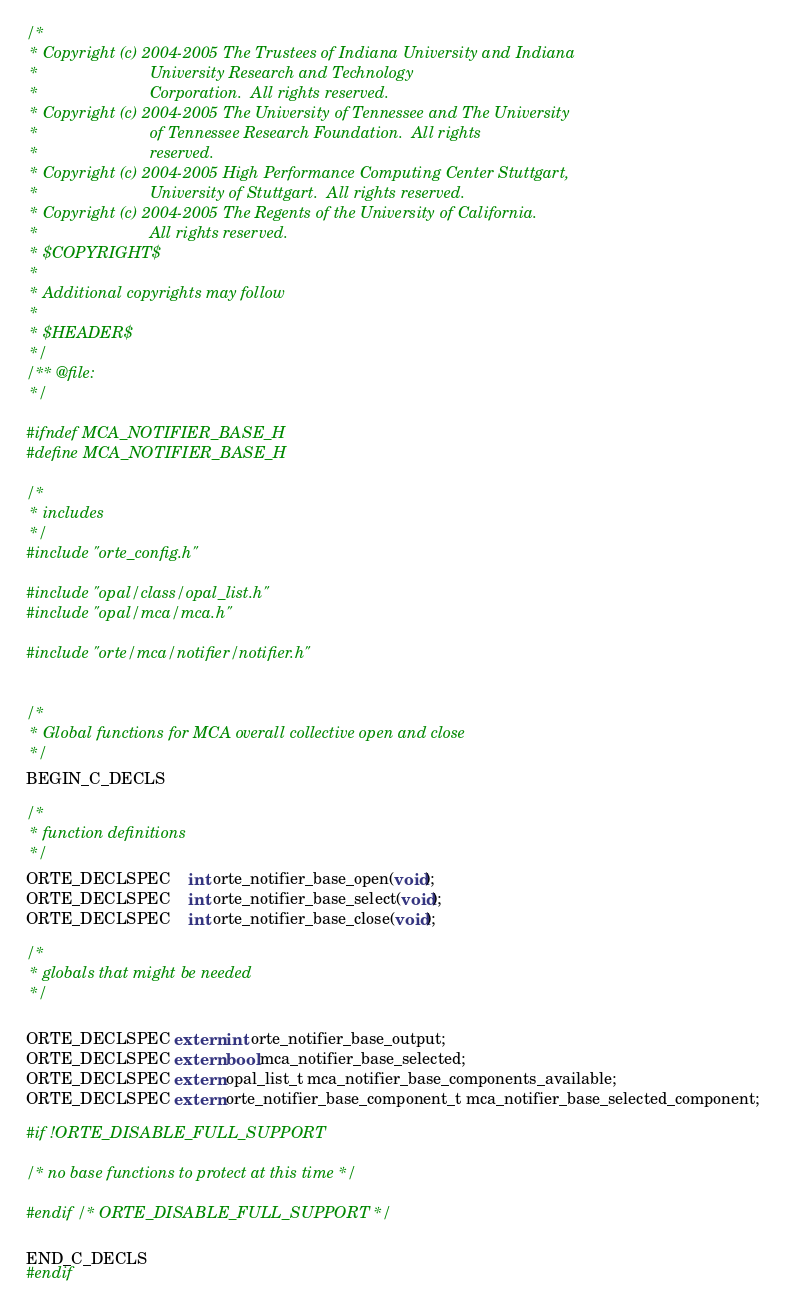<code> <loc_0><loc_0><loc_500><loc_500><_C_>/*
 * Copyright (c) 2004-2005 The Trustees of Indiana University and Indiana
 *                         University Research and Technology
 *                         Corporation.  All rights reserved.
 * Copyright (c) 2004-2005 The University of Tennessee and The University
 *                         of Tennessee Research Foundation.  All rights
 *                         reserved.
 * Copyright (c) 2004-2005 High Performance Computing Center Stuttgart,
 *                         University of Stuttgart.  All rights reserved.
 * Copyright (c) 2004-2005 The Regents of the University of California.
 *                         All rights reserved.
 * $COPYRIGHT$
 *
 * Additional copyrights may follow
 *
 * $HEADER$
 */
/** @file:
 */

#ifndef MCA_NOTIFIER_BASE_H
#define MCA_NOTIFIER_BASE_H

/*
 * includes
 */
#include "orte_config.h"

#include "opal/class/opal_list.h"
#include "opal/mca/mca.h"

#include "orte/mca/notifier/notifier.h"


/*
 * Global functions for MCA overall collective open and close
 */
BEGIN_C_DECLS

/*
 * function definitions
 */
ORTE_DECLSPEC    int orte_notifier_base_open(void);
ORTE_DECLSPEC    int orte_notifier_base_select(void);
ORTE_DECLSPEC    int orte_notifier_base_close(void);

/*
 * globals that might be needed
 */

ORTE_DECLSPEC extern int orte_notifier_base_output;
ORTE_DECLSPEC extern bool mca_notifier_base_selected;
ORTE_DECLSPEC extern opal_list_t mca_notifier_base_components_available;
ORTE_DECLSPEC extern orte_notifier_base_component_t mca_notifier_base_selected_component;

#if !ORTE_DISABLE_FULL_SUPPORT

/* no base functions to protect at this time */

#endif /* ORTE_DISABLE_FULL_SUPPORT */

END_C_DECLS
#endif
</code> 